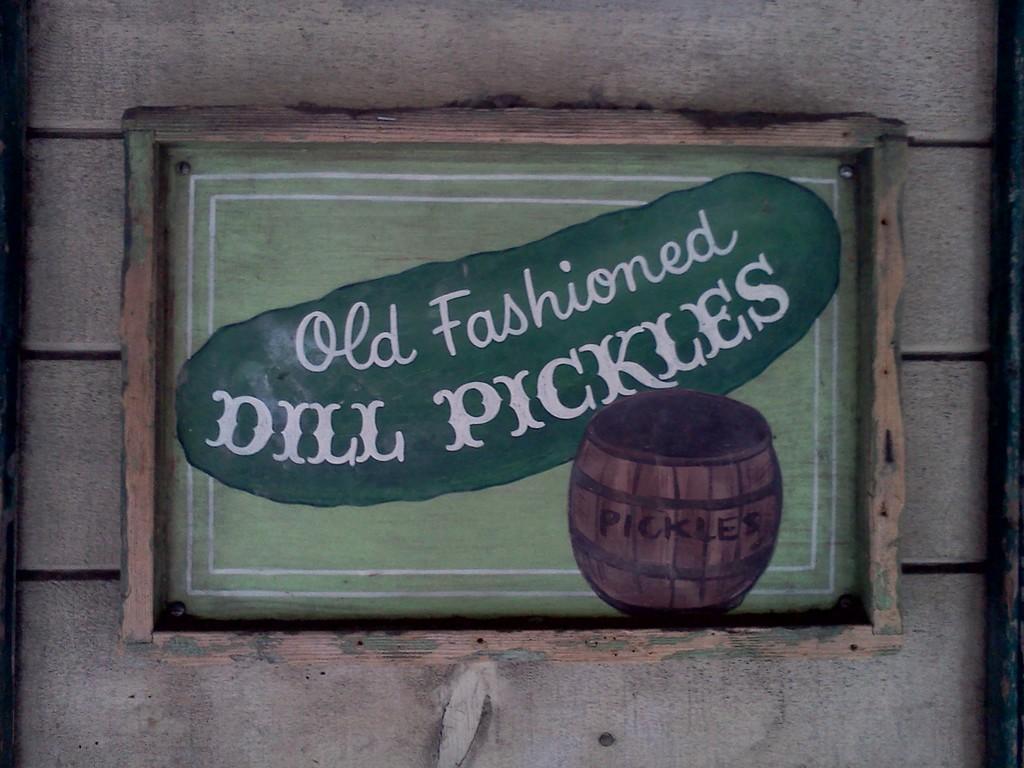Can you describe this image briefly? As we can see in the image there is a wooden wall and a poster. On poster there is a basket and on this it was written as "old fashioned dill pickles". 